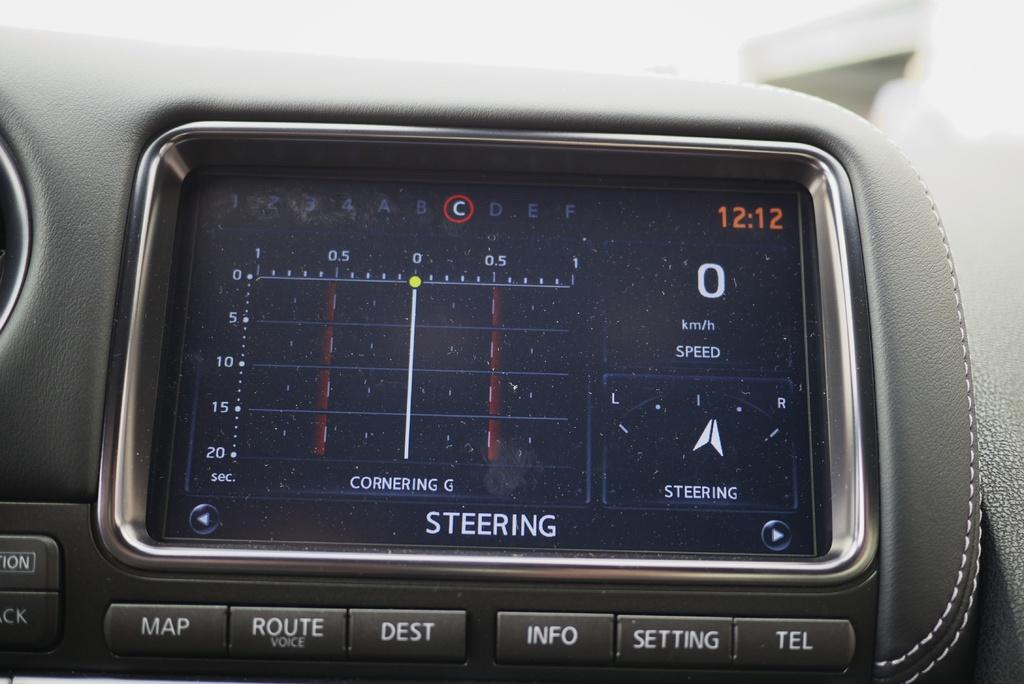What speed are they driving?
Offer a very short reply. 0. What time does the screen show?
Ensure brevity in your answer.  12:12. 